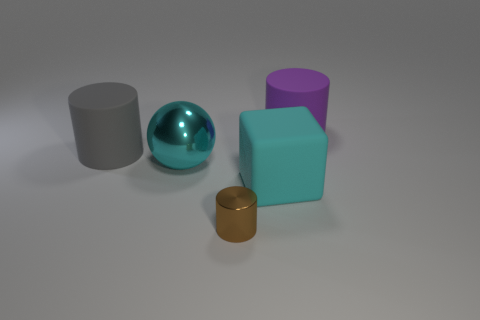Add 1 big metal balls. How many objects exist? 6 Subtract all blocks. How many objects are left? 4 Subtract 0 yellow balls. How many objects are left? 5 Subtract all gray rubber cylinders. Subtract all small brown metal cylinders. How many objects are left? 3 Add 1 big cyan shiny spheres. How many big cyan shiny spheres are left? 2 Add 2 large cylinders. How many large cylinders exist? 4 